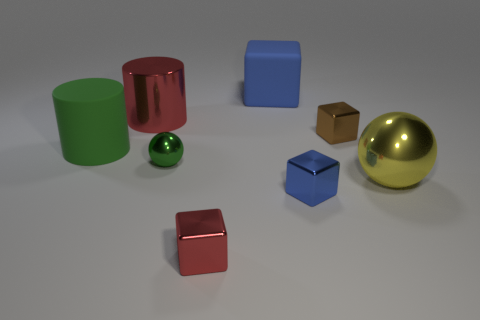Subtract all blue matte cubes. How many cubes are left? 3 Subtract all brown blocks. How many blocks are left? 3 Add 2 tiny gray blocks. How many objects exist? 10 Subtract all cylinders. How many objects are left? 6 Subtract 1 spheres. How many spheres are left? 1 Subtract all green cylinders. How many brown blocks are left? 1 Subtract all yellow blocks. Subtract all green spheres. How many blocks are left? 4 Subtract all brown metallic cubes. Subtract all tiny metal spheres. How many objects are left? 6 Add 7 small blue blocks. How many small blue blocks are left? 8 Add 5 green things. How many green things exist? 7 